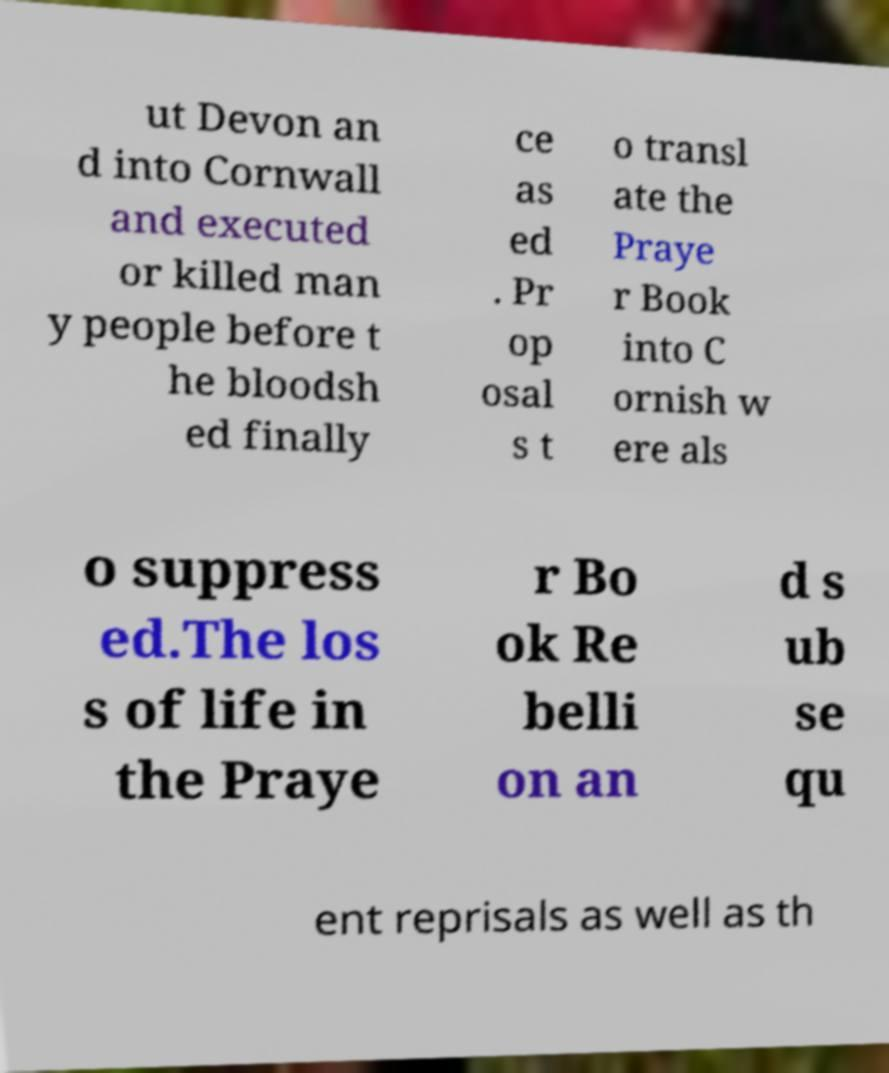What messages or text are displayed in this image? I need them in a readable, typed format. ut Devon an d into Cornwall and executed or killed man y people before t he bloodsh ed finally ce as ed . Pr op osal s t o transl ate the Praye r Book into C ornish w ere als o suppress ed.The los s of life in the Praye r Bo ok Re belli on an d s ub se qu ent reprisals as well as th 